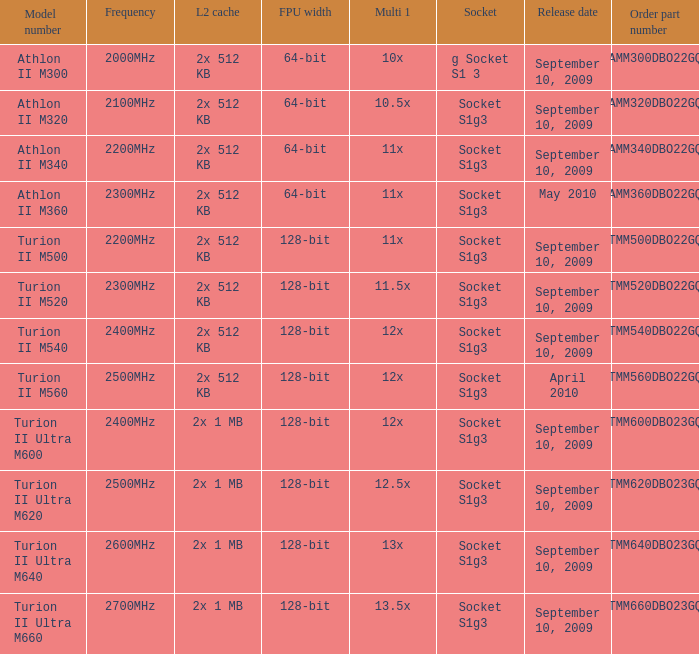What is the introduction date of the 2x 512 kb l2 cache with a 11x multi 1, and a fpu dimension of 128-bit? September 10, 2009. 